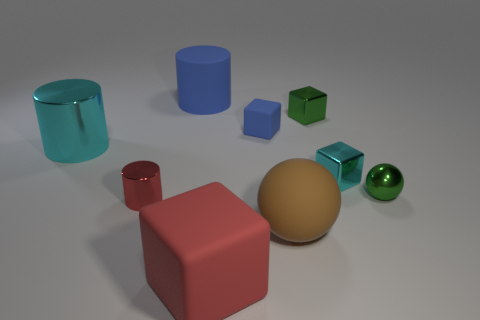There is a red thing that is left of the cylinder that is to the right of the metallic cylinder that is in front of the tiny metal ball; what size is it?
Give a very brief answer. Small. What is the size of the cyan metallic object that is to the left of the big matte cube?
Ensure brevity in your answer.  Large. What number of objects are large brown matte cubes or objects right of the tiny cyan metallic object?
Make the answer very short. 1. How many other things are there of the same size as the blue cylinder?
Ensure brevity in your answer.  3. What is the material of the cyan object that is the same shape as the tiny red metal thing?
Provide a succinct answer. Metal. Is the number of big spheres right of the red rubber object greater than the number of large brown spheres?
Keep it short and to the point. No. Is there any other thing that has the same color as the large metallic thing?
Offer a very short reply. Yes. The small thing that is made of the same material as the red cube is what shape?
Make the answer very short. Cube. Are the red thing left of the big block and the cyan cylinder made of the same material?
Make the answer very short. Yes. There is a rubber thing that is the same color as the small metal cylinder; what is its shape?
Your response must be concise. Cube. 